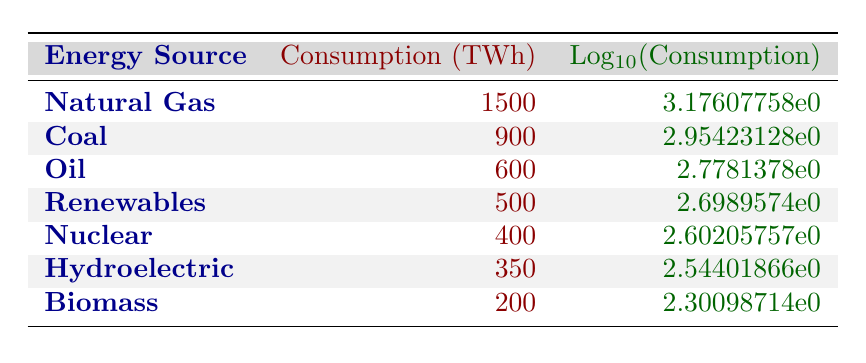What is the total energy consumption from coal and oil? Coal consumption is 900 TWh and oil consumption is 600 TWh. Adding these together gives 900 + 600 = 1500 TWh.
Answer: 1500 TWh Which energy source has the highest consumption in TWh? The table indicates natural gas has the highest consumption, listed as 1500 TWh, higher than any other sources.
Answer: Natural Gas Is the consumption of renewable energy greater than that of nuclear energy? Renewable energy consumption is 500 TWh, while nuclear energy consumption is 400 TWh. Since 500 > 400, the answer is yes.
Answer: Yes What is the logarithmic value of biomass consumption? Biomass consumption is 200 TWh. The logarithmic value is calculated as log10(200), which is approximately 2.30.
Answer: 2.30 What is the difference in consumption between the highest and lowest energy sources? The highest energy source is natural gas at 1500 TWh, and the lowest is biomass at 200 TWh. The difference is 1500 - 200 = 1300 TWh.
Answer: 1300 TWh Are there more TWh consumed from hydroelectric sources than from nuclear sources? The table shows hydroelectric at 350 TWh and nuclear at 400 TWh. Since 350 < 400, the answer is no.
Answer: No What is the average consumption of the top three energy sources? The top three are natural gas (1500 TWh), coal (900 TWh), and oil (600 TWh). The total is 1500 + 900 + 600 = 3000 TWh. The average is 3000 / 3 = 1000 TWh.
Answer: 1000 TWh How many energy sources have a consumption greater than 400 TWh? The sources with greater than 400 TWh are natural gas (1500 TWh), coal (900 TWh), and oil (600 TWh). This totals to three sources.
Answer: 3 What is the total energy consumption from non-renewables? The non-renewables are natural gas (1500 TWh), coal (900 TWh), and oil (600 TWh). Adding these together gives 1500 + 900 + 600 = 3000 TWh.
Answer: 3000 TWh 